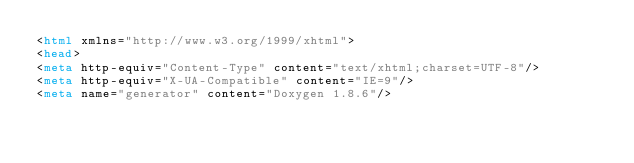<code> <loc_0><loc_0><loc_500><loc_500><_HTML_><html xmlns="http://www.w3.org/1999/xhtml">
<head>
<meta http-equiv="Content-Type" content="text/xhtml;charset=UTF-8"/>
<meta http-equiv="X-UA-Compatible" content="IE=9"/>
<meta name="generator" content="Doxygen 1.8.6"/></code> 